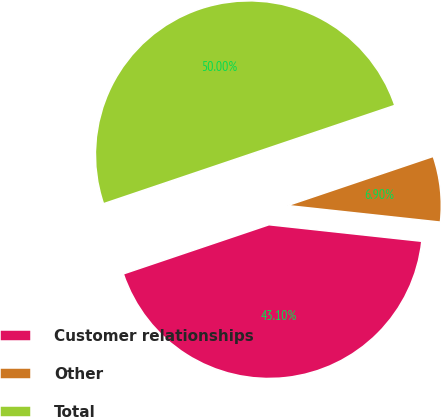Convert chart to OTSL. <chart><loc_0><loc_0><loc_500><loc_500><pie_chart><fcel>Customer relationships<fcel>Other<fcel>Total<nl><fcel>43.1%<fcel>6.9%<fcel>50.0%<nl></chart> 